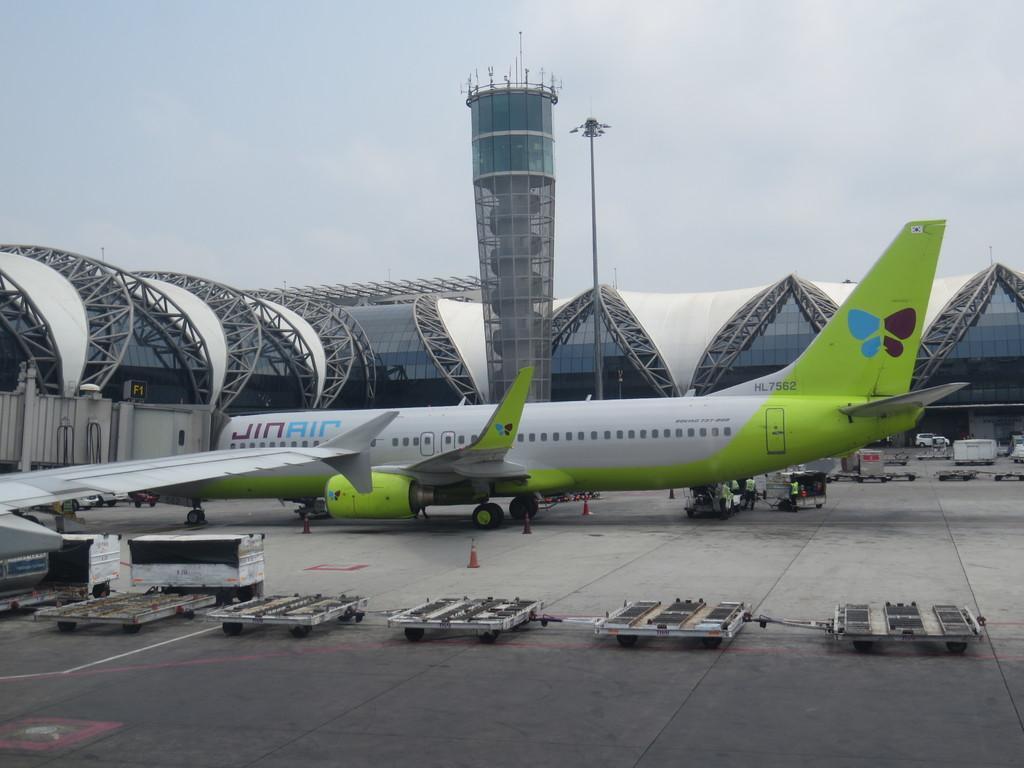How would you summarize this image in a sentence or two? In the picture we can see an airplane which is in green and white color is parked, there are some vehicles, persons standing near the airplane and top of the picture there is cloudy sky. 